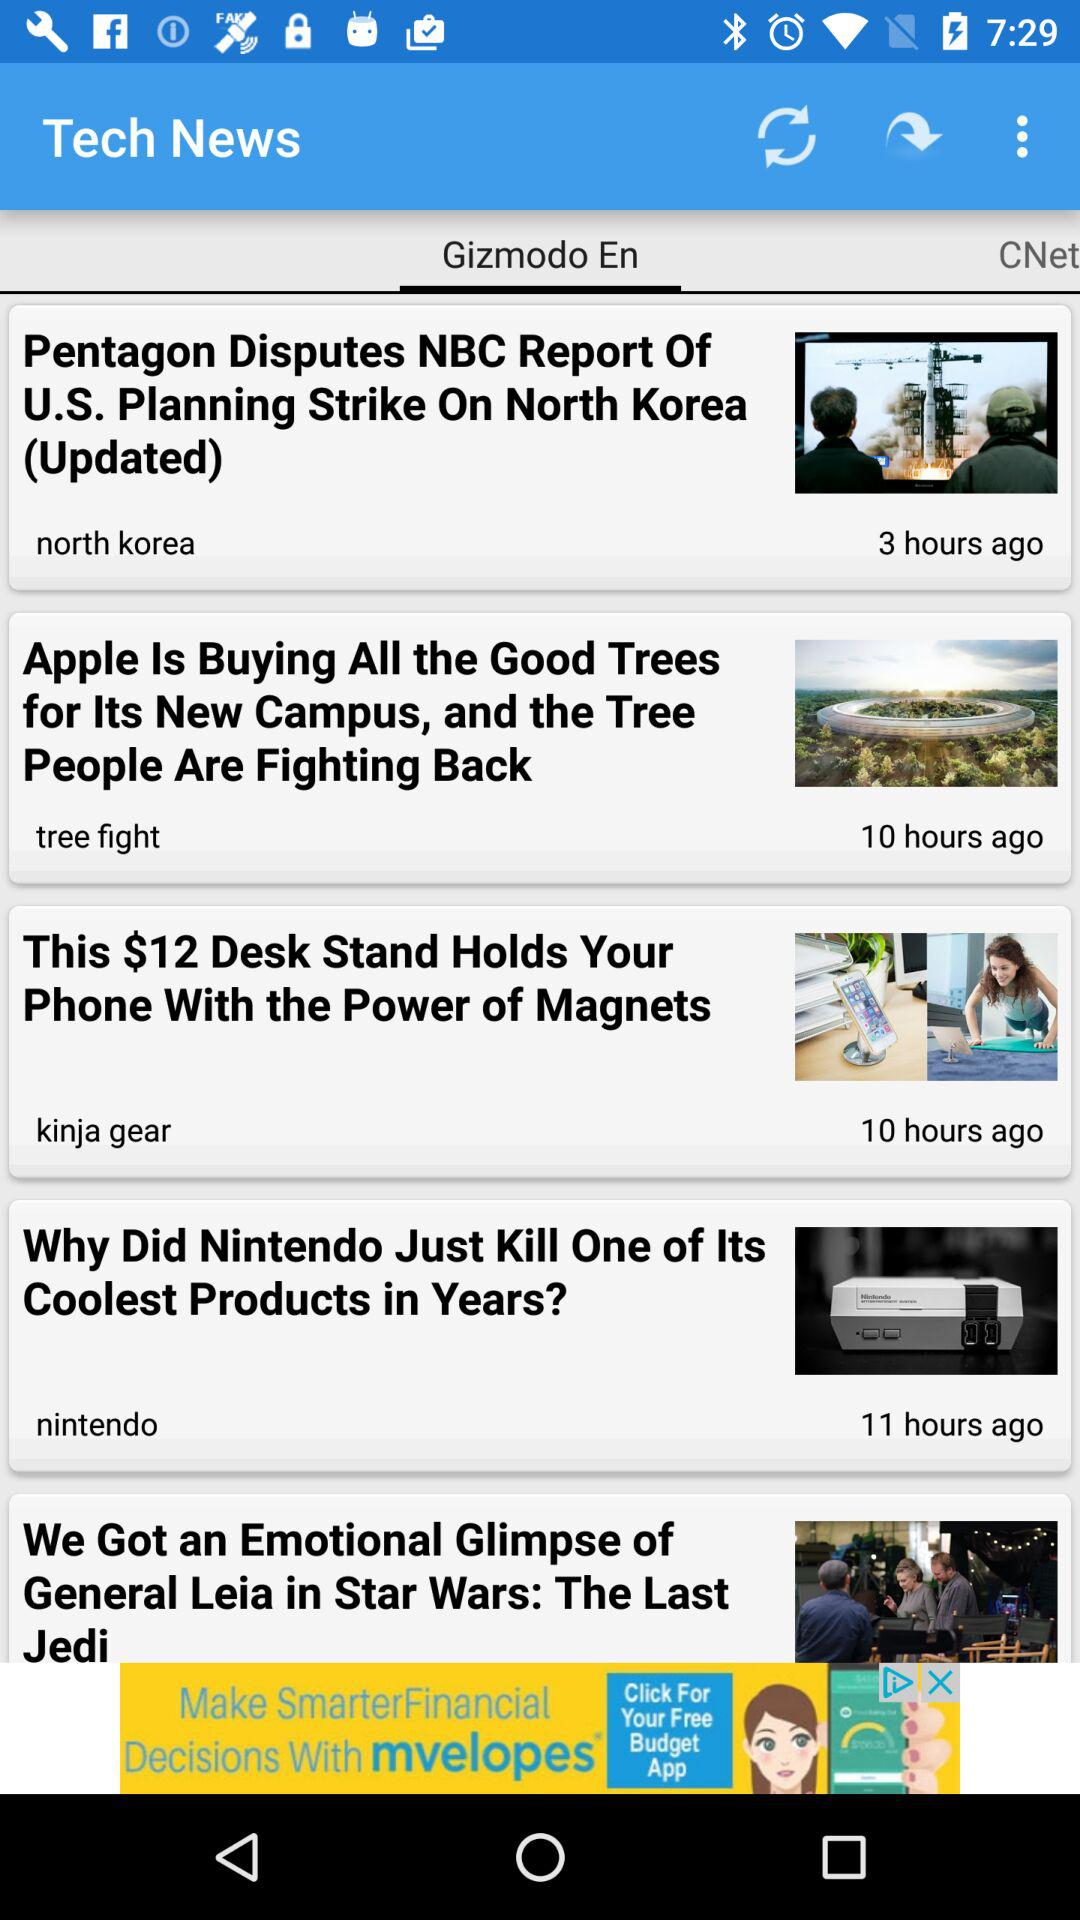How many hours ago was the updated news about North Korea posted? The updated news about North Korea was posted 3 hours ago. 